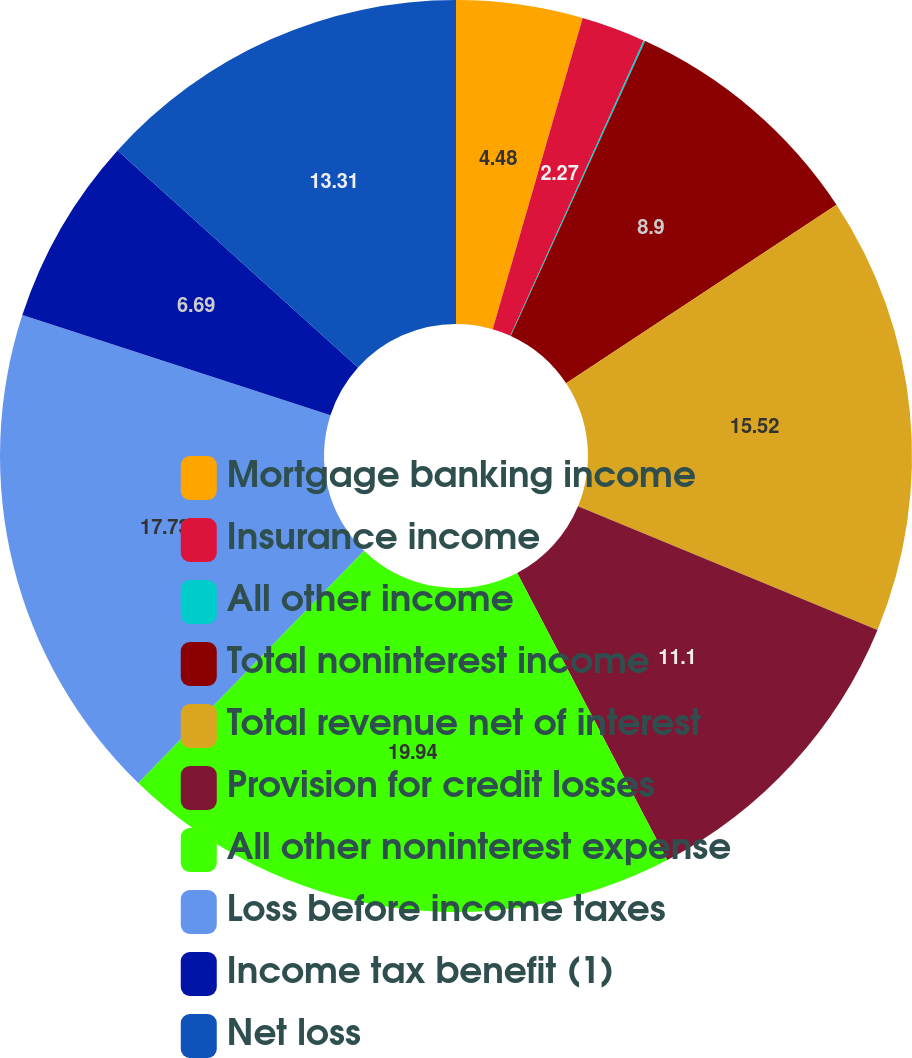Convert chart. <chart><loc_0><loc_0><loc_500><loc_500><pie_chart><fcel>Mortgage banking income<fcel>Insurance income<fcel>All other income<fcel>Total noninterest income<fcel>Total revenue net of interest<fcel>Provision for credit losses<fcel>All other noninterest expense<fcel>Loss before income taxes<fcel>Income tax benefit (1)<fcel>Net loss<nl><fcel>4.48%<fcel>2.27%<fcel>0.06%<fcel>8.9%<fcel>15.52%<fcel>11.1%<fcel>19.94%<fcel>17.73%<fcel>6.69%<fcel>13.31%<nl></chart> 